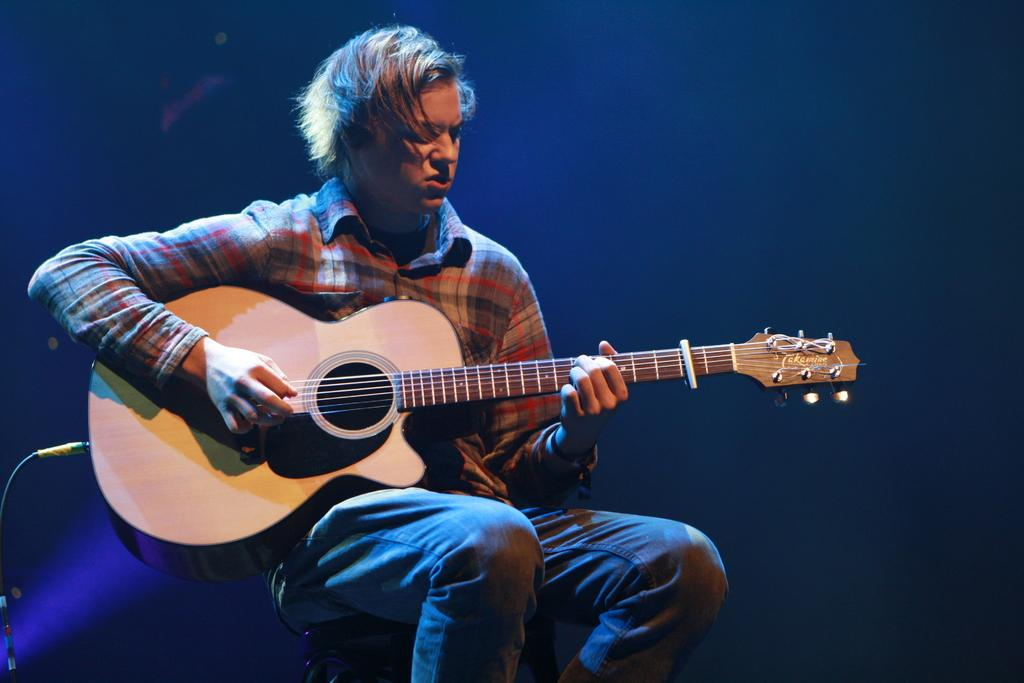What is the main subject of the image? There is a person in the image. What is the person wearing? The person is wearing a checkered shirt. What is the person holding? The person is holding a guitar. What is the person doing with the guitar? The person is playing the guitar. What color is the background of the image? The background of the image is blue. What is the person sitting on? The person is sitting on something, but the specific object is not mentioned in the facts. What type of iron is the person using to gain knowledge in the image? There is no iron or any indication of gaining knowledge present in the image. 